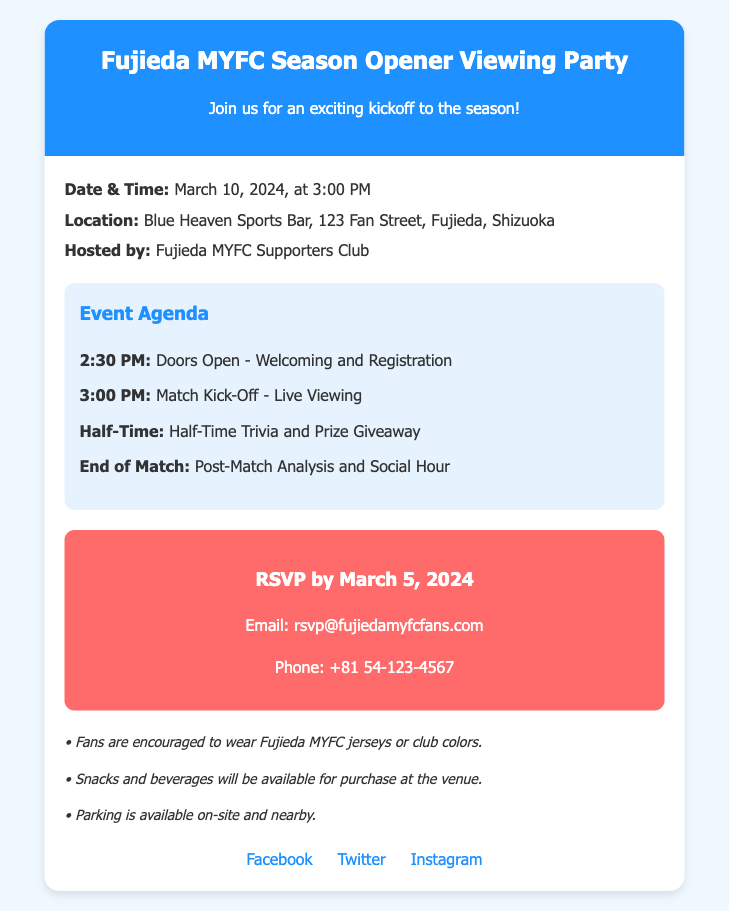What is the date of the viewing party? The date of the event is clearly stated in the document as March 10, 2024.
Answer: March 10, 2024 What time does the match kick-off? The document specifies that the match kick-off is scheduled for 3:00 PM.
Answer: 3:00 PM Where is the viewing party held? The location mentioned in the document is Blue Heaven Sports Bar, 123 Fan Street, Fujieda, Shizuoka.
Answer: Blue Heaven Sports Bar, 123 Fan Street, Fujieda, Shizuoka When is the RSVP deadline? The RSVP deadline is explicitly noted in the document as March 5, 2024.
Answer: March 5, 2024 What is the first event in the agenda? According to the document, the first event is "Doors Open - Welcoming and Registration" at 2:30 PM.
Answer: Doors Open - Welcoming and Registration What will happen during half-time? The document explains that there will be "Half-Time Trivia and Prize Giveaway" at half-time.
Answer: Half-Time Trivia and Prize Giveaway Who is hosting the event? The hosting organization for the event is mentioned as the Fujieda MYFC Supporters Club.
Answer: Fujieda MYFC Supporters Club What is encouraged for fans to wear? The document encourages fans to wear Fujieda MYFC jerseys or club colors.
Answer: Fujieda MYFC jerseys or club colors 